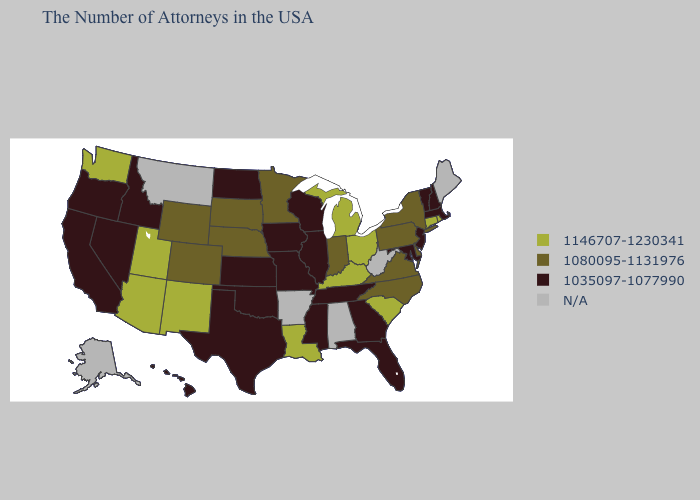Name the states that have a value in the range 1146707-1230341?
Keep it brief. Rhode Island, Connecticut, South Carolina, Ohio, Michigan, Kentucky, Louisiana, New Mexico, Utah, Arizona, Washington. What is the highest value in states that border Arizona?
Answer briefly. 1146707-1230341. Name the states that have a value in the range 1035097-1077990?
Quick response, please. Massachusetts, New Hampshire, Vermont, New Jersey, Maryland, Florida, Georgia, Tennessee, Wisconsin, Illinois, Mississippi, Missouri, Iowa, Kansas, Oklahoma, Texas, North Dakota, Idaho, Nevada, California, Oregon, Hawaii. Does Ohio have the highest value in the USA?
Quick response, please. Yes. Name the states that have a value in the range 1080095-1131976?
Write a very short answer. New York, Delaware, Pennsylvania, Virginia, North Carolina, Indiana, Minnesota, Nebraska, South Dakota, Wyoming, Colorado. Name the states that have a value in the range 1080095-1131976?
Keep it brief. New York, Delaware, Pennsylvania, Virginia, North Carolina, Indiana, Minnesota, Nebraska, South Dakota, Wyoming, Colorado. Which states have the lowest value in the South?
Quick response, please. Maryland, Florida, Georgia, Tennessee, Mississippi, Oklahoma, Texas. What is the highest value in the USA?
Keep it brief. 1146707-1230341. Is the legend a continuous bar?
Short answer required. No. What is the value of Kansas?
Answer briefly. 1035097-1077990. Does the map have missing data?
Quick response, please. Yes. What is the value of Vermont?
Concise answer only. 1035097-1077990. Does the first symbol in the legend represent the smallest category?
Be succinct. No. Is the legend a continuous bar?
Give a very brief answer. No. What is the highest value in the USA?
Quick response, please. 1146707-1230341. 